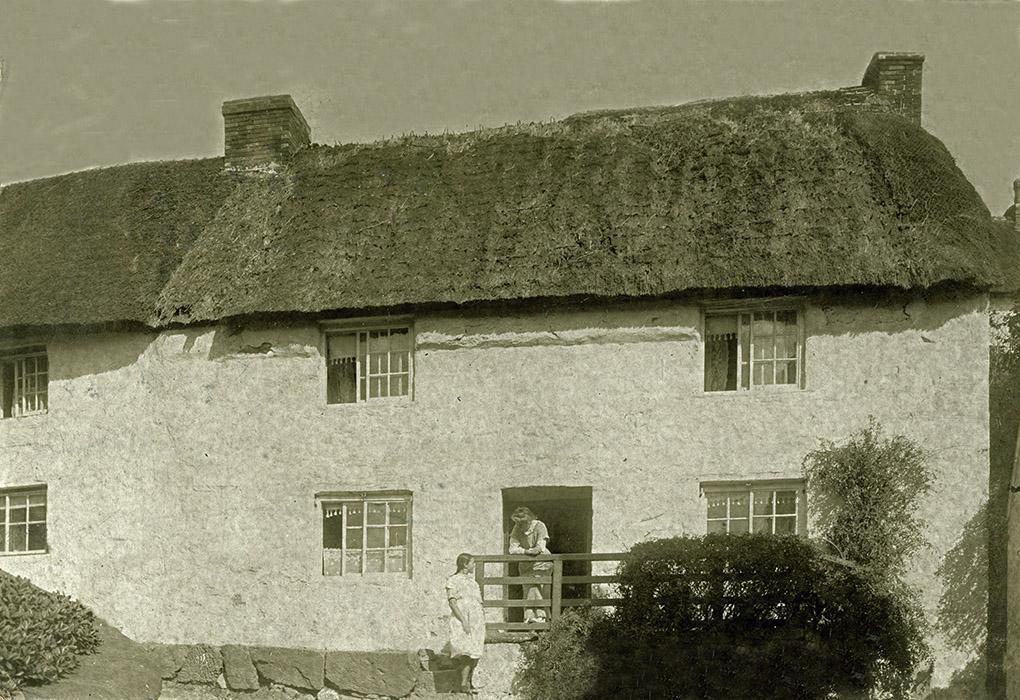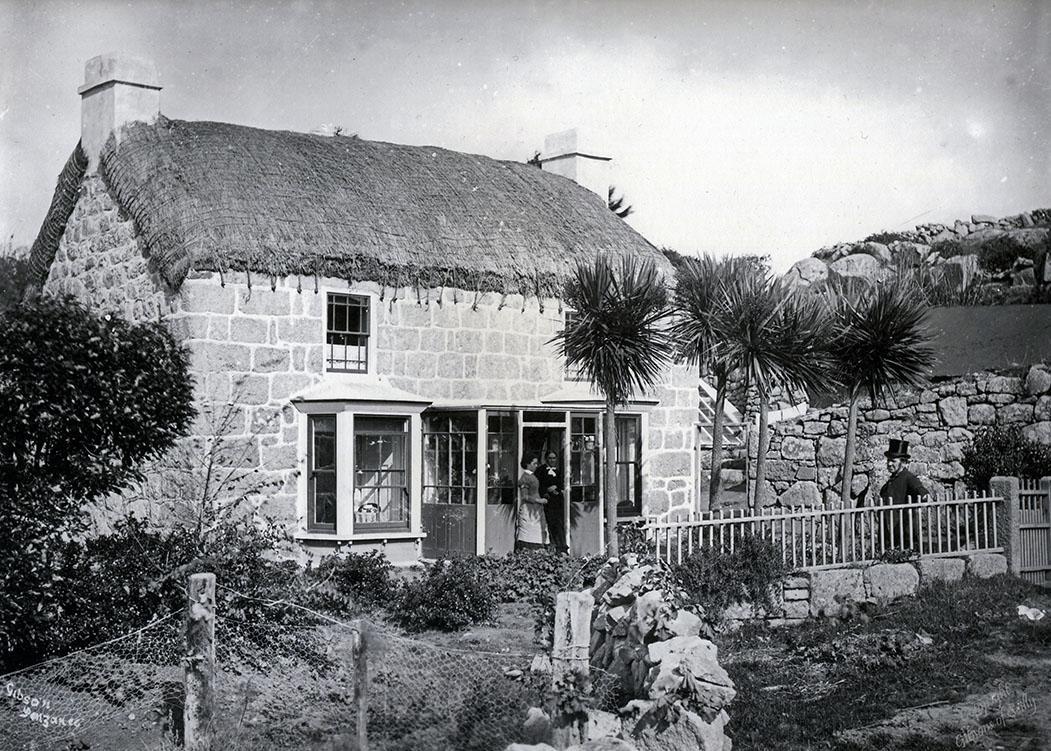The first image is the image on the left, the second image is the image on the right. Considering the images on both sides, is "One image shows buildings with smooth, flat, straight roofs, and the the other image shows rustic-looking stone buildings with roofs that are textured and uneven-looking." valid? Answer yes or no. No. 